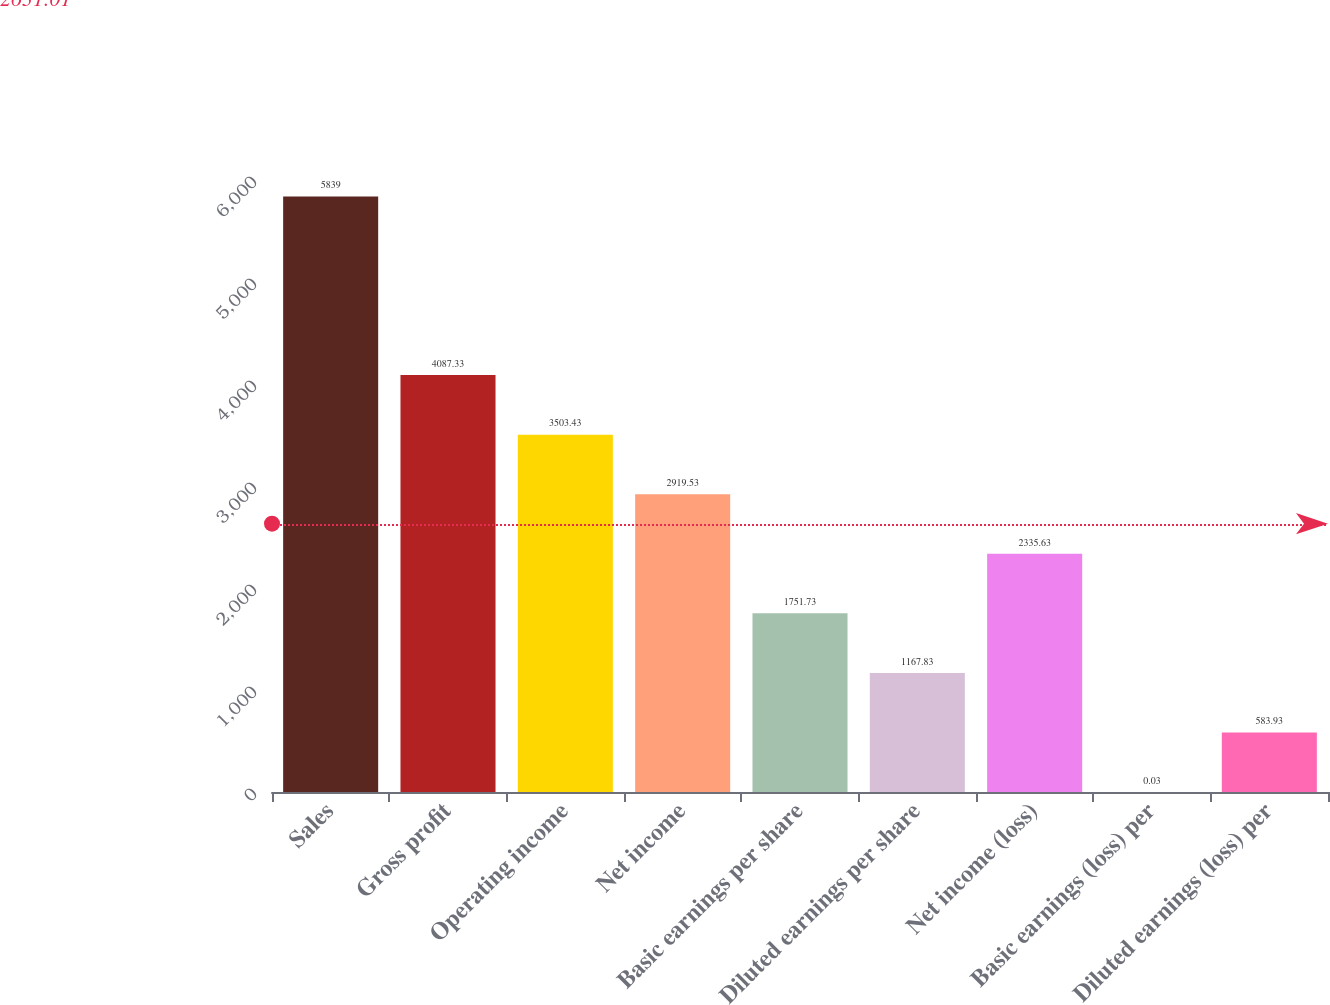Convert chart. <chart><loc_0><loc_0><loc_500><loc_500><bar_chart><fcel>Sales<fcel>Gross profit<fcel>Operating income<fcel>Net income<fcel>Basic earnings per share<fcel>Diluted earnings per share<fcel>Net income (loss)<fcel>Basic earnings (loss) per<fcel>Diluted earnings (loss) per<nl><fcel>5839<fcel>4087.33<fcel>3503.43<fcel>2919.53<fcel>1751.73<fcel>1167.83<fcel>2335.63<fcel>0.03<fcel>583.93<nl></chart> 